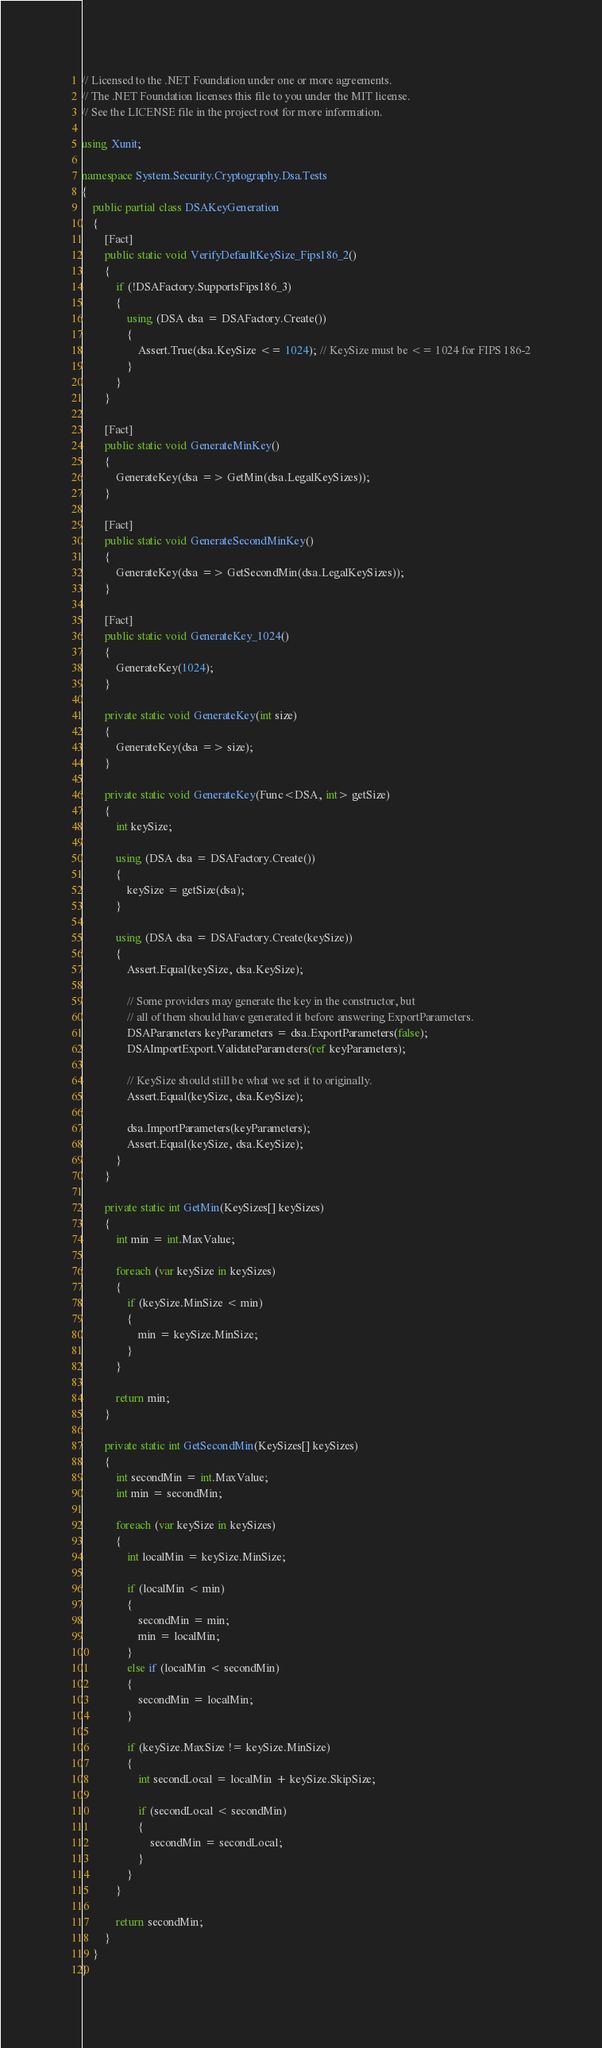<code> <loc_0><loc_0><loc_500><loc_500><_C#_>// Licensed to the .NET Foundation under one or more agreements.
// The .NET Foundation licenses this file to you under the MIT license.
// See the LICENSE file in the project root for more information.

using Xunit;

namespace System.Security.Cryptography.Dsa.Tests
{
    public partial class DSAKeyGeneration
    {
        [Fact]
        public static void VerifyDefaultKeySize_Fips186_2()
        {
            if (!DSAFactory.SupportsFips186_3)
            {
                using (DSA dsa = DSAFactory.Create())
                {
                    Assert.True(dsa.KeySize <= 1024); // KeySize must be <= 1024 for FIPS 186-2
                }
            }
        }

        [Fact]
        public static void GenerateMinKey()
        {
            GenerateKey(dsa => GetMin(dsa.LegalKeySizes));
        }

        [Fact]
        public static void GenerateSecondMinKey()
        {
            GenerateKey(dsa => GetSecondMin(dsa.LegalKeySizes));
        }

        [Fact]
        public static void GenerateKey_1024()
        {
            GenerateKey(1024);
        }

        private static void GenerateKey(int size)
        {
            GenerateKey(dsa => size);
        }

        private static void GenerateKey(Func<DSA, int> getSize)
        {
            int keySize;

            using (DSA dsa = DSAFactory.Create())
            {
                keySize = getSize(dsa);
            }

            using (DSA dsa = DSAFactory.Create(keySize))
            {
                Assert.Equal(keySize, dsa.KeySize);

                // Some providers may generate the key in the constructor, but
                // all of them should have generated it before answering ExportParameters.
                DSAParameters keyParameters = dsa.ExportParameters(false);
                DSAImportExport.ValidateParameters(ref keyParameters);

                // KeySize should still be what we set it to originally.
                Assert.Equal(keySize, dsa.KeySize);

                dsa.ImportParameters(keyParameters);
                Assert.Equal(keySize, dsa.KeySize);
            }
        }

        private static int GetMin(KeySizes[] keySizes)
        {
            int min = int.MaxValue;

            foreach (var keySize in keySizes)
            {
                if (keySize.MinSize < min)
                {
                    min = keySize.MinSize;
                }
            }

            return min;
        }

        private static int GetSecondMin(KeySizes[] keySizes)
        {
            int secondMin = int.MaxValue;
            int min = secondMin;

            foreach (var keySize in keySizes)
            {
                int localMin = keySize.MinSize;

                if (localMin < min)
                {
                    secondMin = min;
                    min = localMin;
                }
                else if (localMin < secondMin)
                {
                    secondMin = localMin;
                }

                if (keySize.MaxSize != keySize.MinSize)
                {
                    int secondLocal = localMin + keySize.SkipSize;

                    if (secondLocal < secondMin)
                    {
                        secondMin = secondLocal;
                    }
                }
            }

            return secondMin;
        }
    }
}</code> 